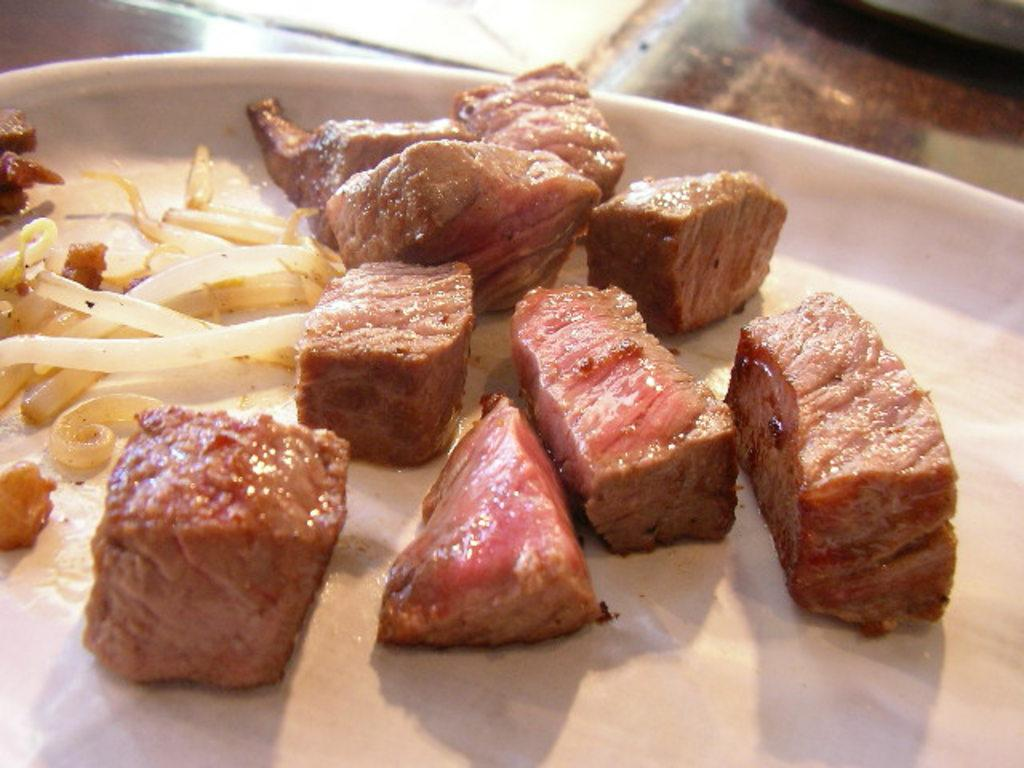What type of food can be seen in the image? There are meat pieces and noodles in the image. How are the meat and noodles arranged in the image? The meat and noodles are on a white platter. What is the surface beneath the platter? The platter is on a tile surface. What can be seen in the top right of the image? There is a black object in the top right of the image. How many sheep are visible in the image? There are no sheep present in the image. What type of work is being done in the image? There is no indication of any work being done in the image. 